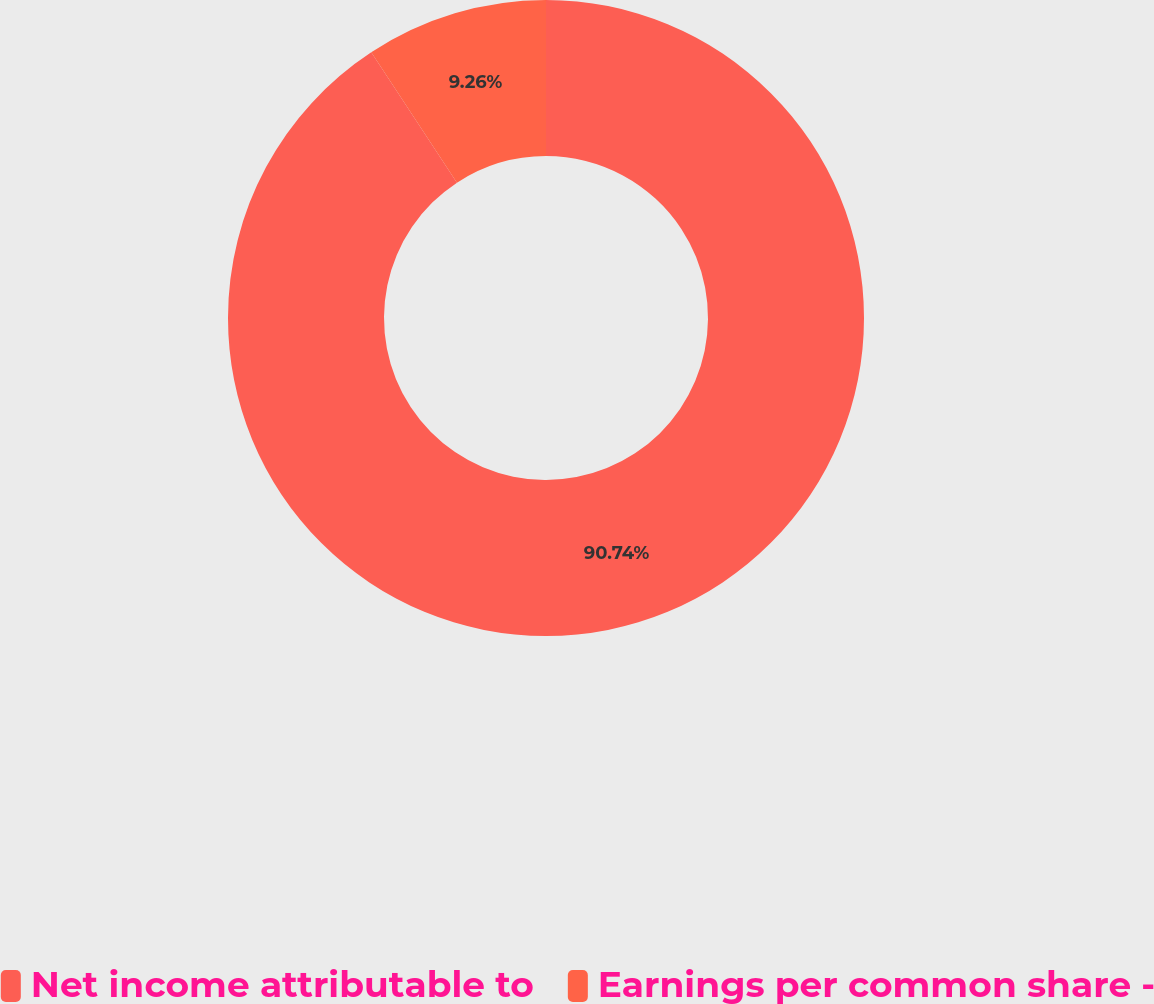<chart> <loc_0><loc_0><loc_500><loc_500><pie_chart><fcel>Net income attributable to<fcel>Earnings per common share -<nl><fcel>90.74%<fcel>9.26%<nl></chart> 